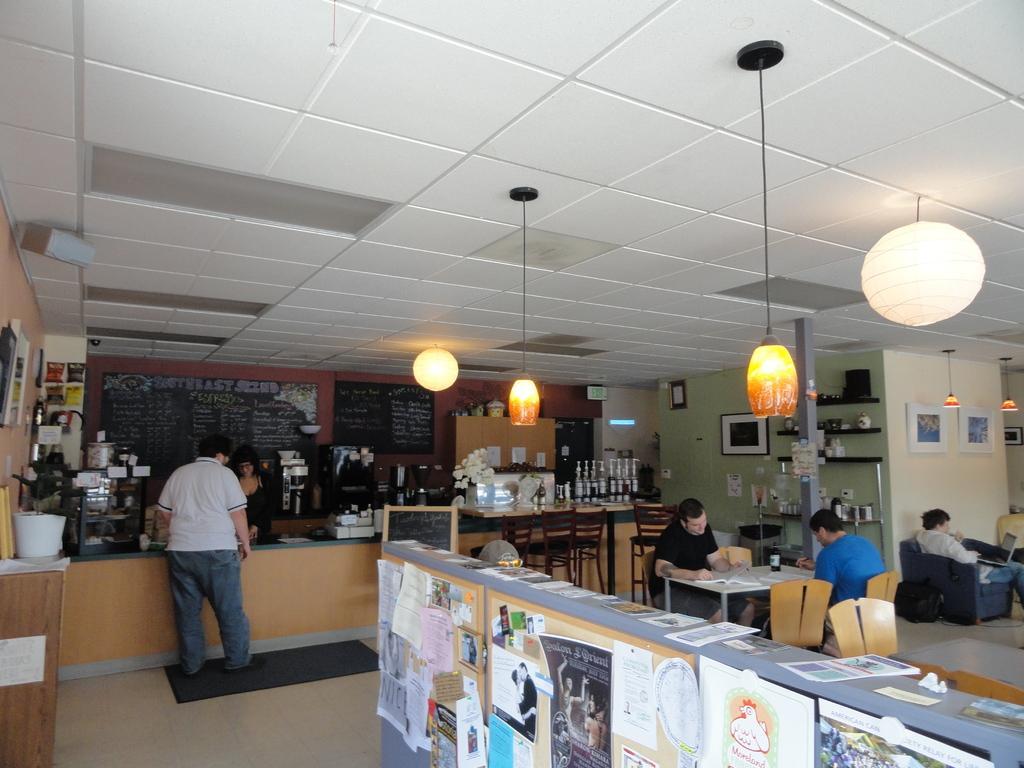How would you summarize this image in a sentence or two? We can see posts attached on surface and we can see papers and some objects on the table. There are people sitting on chairs and this person standing on mat and we can see books and bottle on the table. On the left side side of the image we can see papers and objects on the table. In the background we can see a person and we can see flowers,bottles and objects on the shelf and frames and boards on walls. At the top we can see lights. 